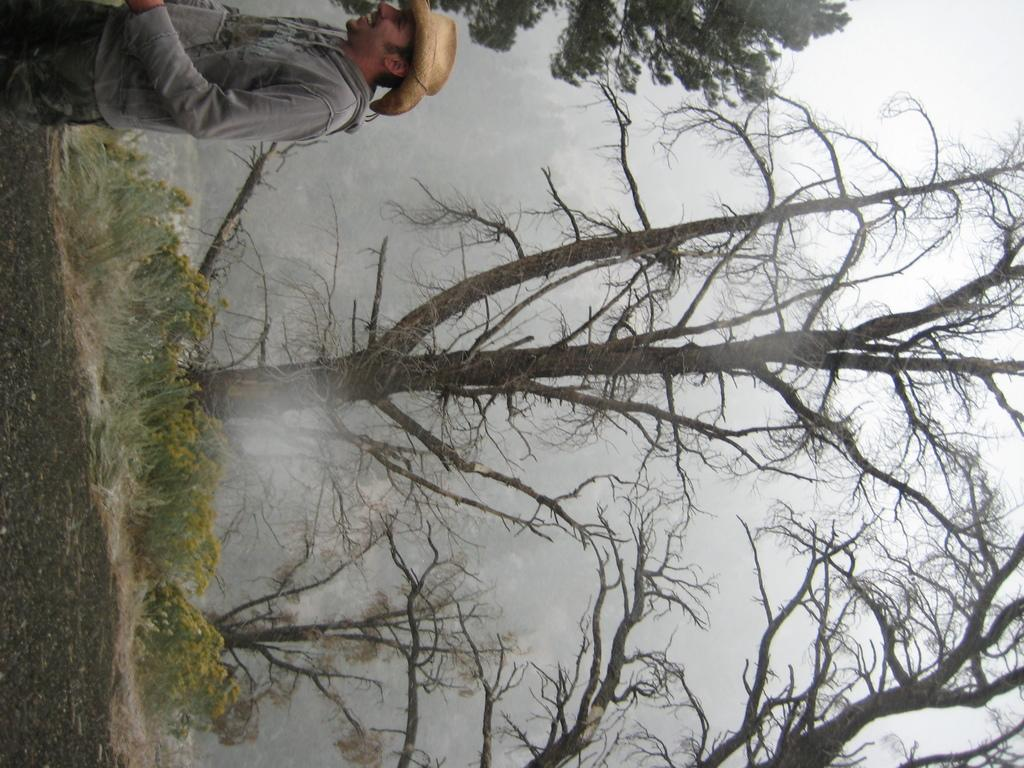What is the main subject in the image? There is a person standing in the image. What can be seen in the background of the image? There are plants with flowers and trees in the background. What else is visible in the background of the image? The sky is visible in the background. What type of thrill can be seen on the laborer's face in the image? There is no laborer present in the image, and therefore no facial expression to describe. 